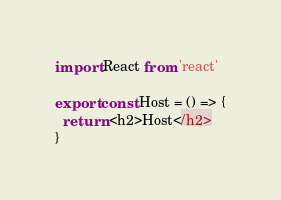<code> <loc_0><loc_0><loc_500><loc_500><_TypeScript_>import React from 'react'

export const Host = () => {
  return <h2>Host</h2>
}
</code> 